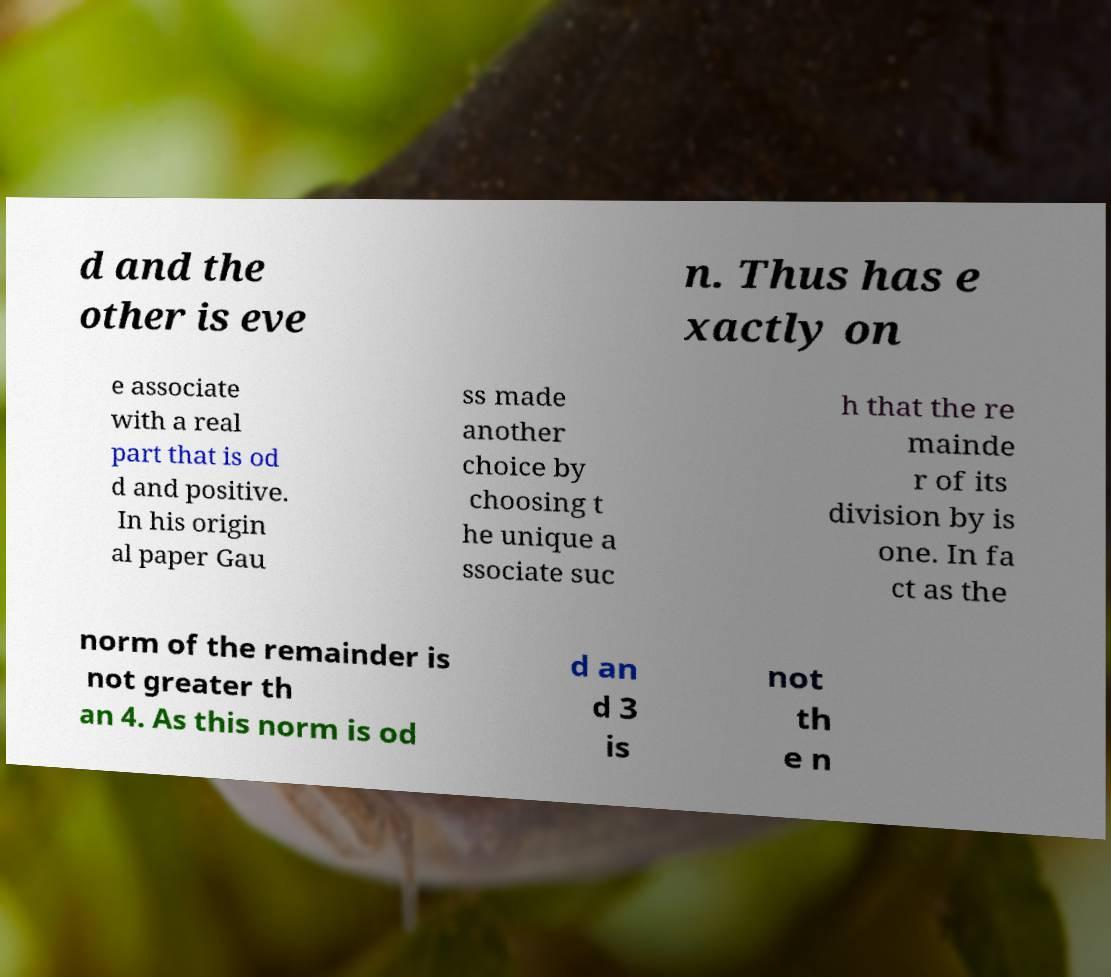What messages or text are displayed in this image? I need them in a readable, typed format. d and the other is eve n. Thus has e xactly on e associate with a real part that is od d and positive. In his origin al paper Gau ss made another choice by choosing t he unique a ssociate suc h that the re mainde r of its division by is one. In fa ct as the norm of the remainder is not greater th an 4. As this norm is od d an d 3 is not th e n 